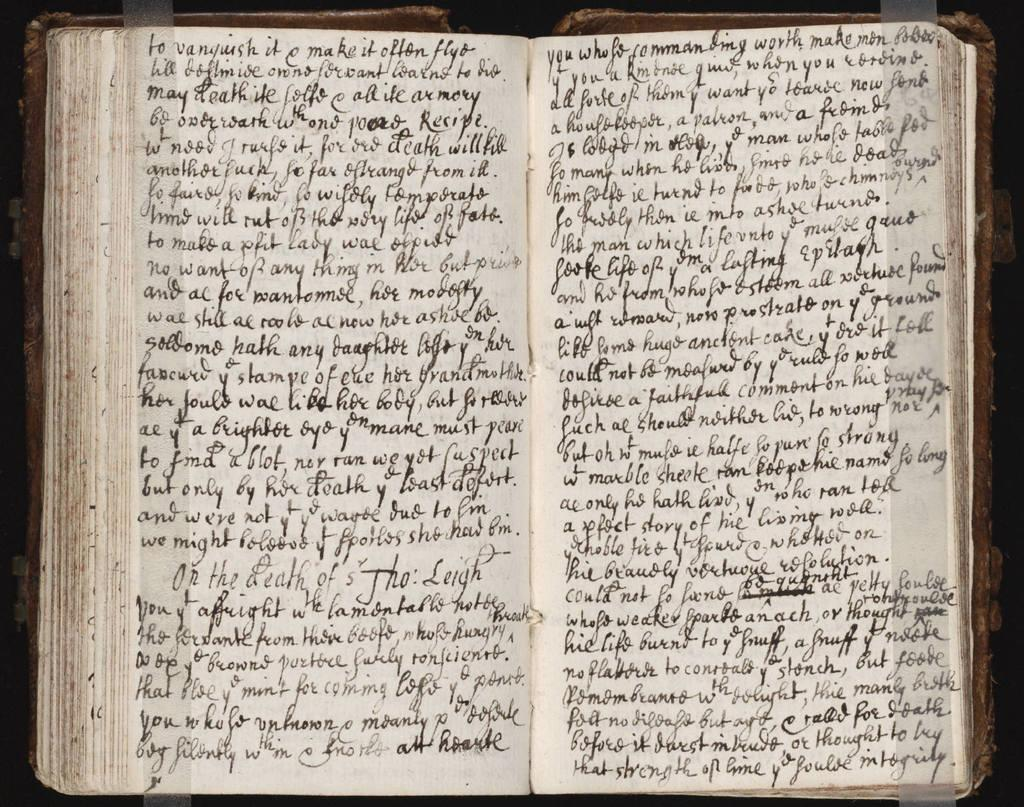What is the main object in the image? There is an opened book in the image. What can be found inside the book? The book contains written text. What type of plate is visible in the image? There is no plate present in the image; it only features an opened book with written text. 